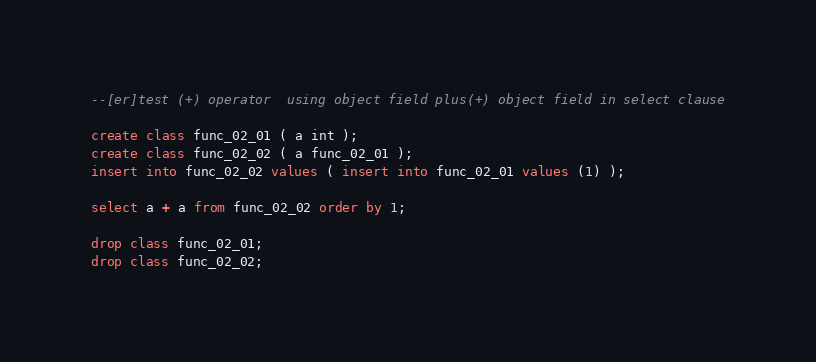Convert code to text. <code><loc_0><loc_0><loc_500><loc_500><_SQL_>--[er]test (+) operator  using object field plus(+) object field in select clause

create class func_02_01 ( a int );
create class func_02_02 ( a func_02_01 );
insert into func_02_02 values ( insert into func_02_01 values (1) );

select a + a from func_02_02 order by 1;

drop class func_02_01;
drop class func_02_02;
</code> 